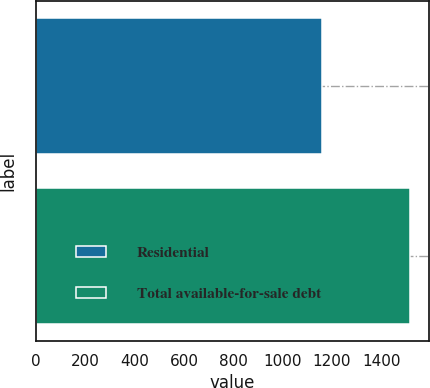Convert chart. <chart><loc_0><loc_0><loc_500><loc_500><bar_chart><fcel>Residential<fcel>Total available-for-sale debt<nl><fcel>1159<fcel>1518<nl></chart> 